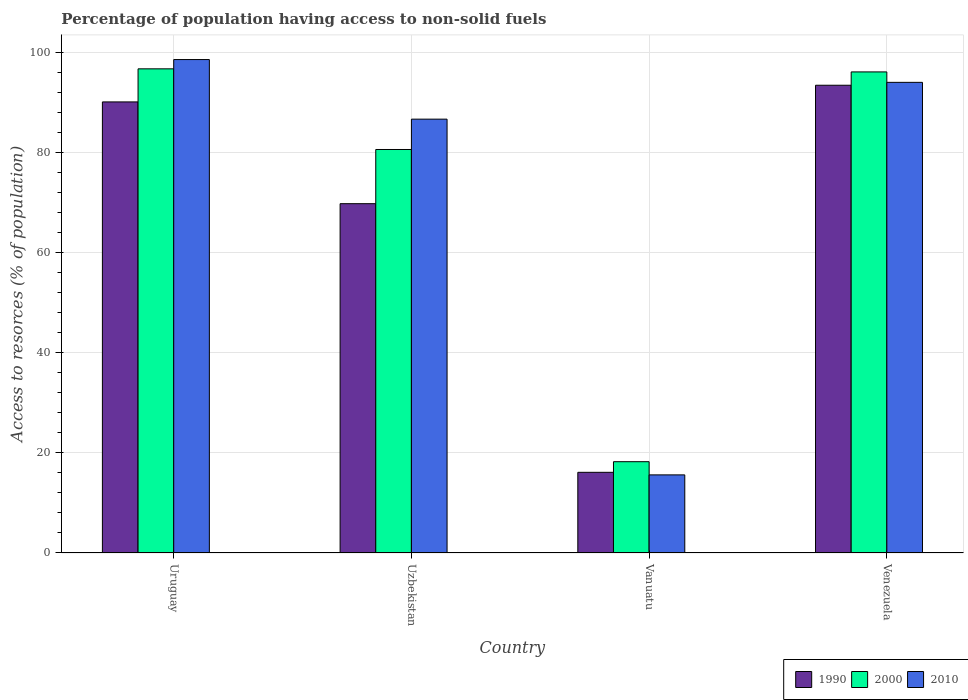Are the number of bars on each tick of the X-axis equal?
Provide a short and direct response. Yes. What is the label of the 1st group of bars from the left?
Provide a succinct answer. Uruguay. What is the percentage of population having access to non-solid fuels in 2010 in Vanuatu?
Make the answer very short. 15.6. Across all countries, what is the maximum percentage of population having access to non-solid fuels in 2010?
Keep it short and to the point. 98.59. Across all countries, what is the minimum percentage of population having access to non-solid fuels in 2000?
Make the answer very short. 18.24. In which country was the percentage of population having access to non-solid fuels in 2000 maximum?
Your response must be concise. Uruguay. In which country was the percentage of population having access to non-solid fuels in 1990 minimum?
Offer a terse response. Vanuatu. What is the total percentage of population having access to non-solid fuels in 2000 in the graph?
Offer a very short reply. 291.7. What is the difference between the percentage of population having access to non-solid fuels in 2010 in Uzbekistan and that in Vanuatu?
Offer a terse response. 71.07. What is the difference between the percentage of population having access to non-solid fuels in 2000 in Venezuela and the percentage of population having access to non-solid fuels in 1990 in Uruguay?
Offer a terse response. 5.99. What is the average percentage of population having access to non-solid fuels in 1990 per country?
Offer a very short reply. 67.37. What is the difference between the percentage of population having access to non-solid fuels of/in 2010 and percentage of population having access to non-solid fuels of/in 2000 in Venezuela?
Make the answer very short. -2.08. In how many countries, is the percentage of population having access to non-solid fuels in 2000 greater than 16 %?
Give a very brief answer. 4. What is the ratio of the percentage of population having access to non-solid fuels in 1990 in Uruguay to that in Vanuatu?
Give a very brief answer. 5.59. Is the percentage of population having access to non-solid fuels in 2010 in Uzbekistan less than that in Venezuela?
Offer a terse response. Yes. What is the difference between the highest and the second highest percentage of population having access to non-solid fuels in 2010?
Offer a terse response. -11.91. What is the difference between the highest and the lowest percentage of population having access to non-solid fuels in 2000?
Offer a very short reply. 78.49. Is the sum of the percentage of population having access to non-solid fuels in 1990 in Uruguay and Vanuatu greater than the maximum percentage of population having access to non-solid fuels in 2000 across all countries?
Offer a terse response. Yes. What does the 3rd bar from the left in Uzbekistan represents?
Offer a very short reply. 2010. What does the 1st bar from the right in Venezuela represents?
Your answer should be compact. 2010. Are the values on the major ticks of Y-axis written in scientific E-notation?
Your answer should be very brief. No. Does the graph contain any zero values?
Offer a very short reply. No. How many legend labels are there?
Your response must be concise. 3. What is the title of the graph?
Offer a terse response. Percentage of population having access to non-solid fuels. What is the label or title of the Y-axis?
Keep it short and to the point. Access to resorces (% of population). What is the Access to resorces (% of population) of 1990 in Uruguay?
Provide a short and direct response. 90.12. What is the Access to resorces (% of population) in 2000 in Uruguay?
Give a very brief answer. 96.73. What is the Access to resorces (% of population) in 2010 in Uruguay?
Your response must be concise. 98.59. What is the Access to resorces (% of population) of 1990 in Uzbekistan?
Offer a terse response. 69.79. What is the Access to resorces (% of population) in 2000 in Uzbekistan?
Offer a terse response. 80.62. What is the Access to resorces (% of population) in 2010 in Uzbekistan?
Offer a very short reply. 86.68. What is the Access to resorces (% of population) in 1990 in Vanuatu?
Your response must be concise. 16.12. What is the Access to resorces (% of population) of 2000 in Vanuatu?
Ensure brevity in your answer.  18.24. What is the Access to resorces (% of population) of 2010 in Vanuatu?
Your response must be concise. 15.6. What is the Access to resorces (% of population) of 1990 in Venezuela?
Ensure brevity in your answer.  93.45. What is the Access to resorces (% of population) in 2000 in Venezuela?
Offer a terse response. 96.12. What is the Access to resorces (% of population) in 2010 in Venezuela?
Provide a succinct answer. 94.03. Across all countries, what is the maximum Access to resorces (% of population) in 1990?
Offer a terse response. 93.45. Across all countries, what is the maximum Access to resorces (% of population) of 2000?
Provide a succinct answer. 96.73. Across all countries, what is the maximum Access to resorces (% of population) in 2010?
Make the answer very short. 98.59. Across all countries, what is the minimum Access to resorces (% of population) of 1990?
Provide a short and direct response. 16.12. Across all countries, what is the minimum Access to resorces (% of population) of 2000?
Offer a terse response. 18.24. Across all countries, what is the minimum Access to resorces (% of population) of 2010?
Make the answer very short. 15.6. What is the total Access to resorces (% of population) of 1990 in the graph?
Your answer should be compact. 269.48. What is the total Access to resorces (% of population) in 2000 in the graph?
Give a very brief answer. 291.7. What is the total Access to resorces (% of population) of 2010 in the graph?
Provide a succinct answer. 294.9. What is the difference between the Access to resorces (% of population) in 1990 in Uruguay and that in Uzbekistan?
Keep it short and to the point. 20.33. What is the difference between the Access to resorces (% of population) of 2000 in Uruguay and that in Uzbekistan?
Make the answer very short. 16.12. What is the difference between the Access to resorces (% of population) in 2010 in Uruguay and that in Uzbekistan?
Your answer should be compact. 11.91. What is the difference between the Access to resorces (% of population) of 1990 in Uruguay and that in Vanuatu?
Give a very brief answer. 74.01. What is the difference between the Access to resorces (% of population) of 2000 in Uruguay and that in Vanuatu?
Give a very brief answer. 78.49. What is the difference between the Access to resorces (% of population) in 2010 in Uruguay and that in Vanuatu?
Give a very brief answer. 82.98. What is the difference between the Access to resorces (% of population) in 1990 in Uruguay and that in Venezuela?
Your response must be concise. -3.33. What is the difference between the Access to resorces (% of population) of 2000 in Uruguay and that in Venezuela?
Ensure brevity in your answer.  0.62. What is the difference between the Access to resorces (% of population) of 2010 in Uruguay and that in Venezuela?
Your answer should be very brief. 4.55. What is the difference between the Access to resorces (% of population) of 1990 in Uzbekistan and that in Vanuatu?
Your response must be concise. 53.67. What is the difference between the Access to resorces (% of population) of 2000 in Uzbekistan and that in Vanuatu?
Give a very brief answer. 62.38. What is the difference between the Access to resorces (% of population) of 2010 in Uzbekistan and that in Vanuatu?
Make the answer very short. 71.07. What is the difference between the Access to resorces (% of population) in 1990 in Uzbekistan and that in Venezuela?
Your response must be concise. -23.66. What is the difference between the Access to resorces (% of population) of 2000 in Uzbekistan and that in Venezuela?
Your response must be concise. -15.5. What is the difference between the Access to resorces (% of population) of 2010 in Uzbekistan and that in Venezuela?
Provide a succinct answer. -7.35. What is the difference between the Access to resorces (% of population) in 1990 in Vanuatu and that in Venezuela?
Your answer should be very brief. -77.34. What is the difference between the Access to resorces (% of population) in 2000 in Vanuatu and that in Venezuela?
Offer a terse response. -77.88. What is the difference between the Access to resorces (% of population) of 2010 in Vanuatu and that in Venezuela?
Your answer should be very brief. -78.43. What is the difference between the Access to resorces (% of population) in 1990 in Uruguay and the Access to resorces (% of population) in 2000 in Uzbekistan?
Make the answer very short. 9.51. What is the difference between the Access to resorces (% of population) in 1990 in Uruguay and the Access to resorces (% of population) in 2010 in Uzbekistan?
Make the answer very short. 3.44. What is the difference between the Access to resorces (% of population) of 2000 in Uruguay and the Access to resorces (% of population) of 2010 in Uzbekistan?
Provide a succinct answer. 10.05. What is the difference between the Access to resorces (% of population) in 1990 in Uruguay and the Access to resorces (% of population) in 2000 in Vanuatu?
Ensure brevity in your answer.  71.88. What is the difference between the Access to resorces (% of population) in 1990 in Uruguay and the Access to resorces (% of population) in 2010 in Vanuatu?
Give a very brief answer. 74.52. What is the difference between the Access to resorces (% of population) in 2000 in Uruguay and the Access to resorces (% of population) in 2010 in Vanuatu?
Ensure brevity in your answer.  81.13. What is the difference between the Access to resorces (% of population) in 1990 in Uruguay and the Access to resorces (% of population) in 2000 in Venezuela?
Your response must be concise. -5.99. What is the difference between the Access to resorces (% of population) in 1990 in Uruguay and the Access to resorces (% of population) in 2010 in Venezuela?
Give a very brief answer. -3.91. What is the difference between the Access to resorces (% of population) of 2000 in Uruguay and the Access to resorces (% of population) of 2010 in Venezuela?
Offer a terse response. 2.7. What is the difference between the Access to resorces (% of population) of 1990 in Uzbekistan and the Access to resorces (% of population) of 2000 in Vanuatu?
Provide a short and direct response. 51.55. What is the difference between the Access to resorces (% of population) in 1990 in Uzbekistan and the Access to resorces (% of population) in 2010 in Vanuatu?
Offer a terse response. 54.18. What is the difference between the Access to resorces (% of population) in 2000 in Uzbekistan and the Access to resorces (% of population) in 2010 in Vanuatu?
Provide a short and direct response. 65.01. What is the difference between the Access to resorces (% of population) of 1990 in Uzbekistan and the Access to resorces (% of population) of 2000 in Venezuela?
Keep it short and to the point. -26.33. What is the difference between the Access to resorces (% of population) in 1990 in Uzbekistan and the Access to resorces (% of population) in 2010 in Venezuela?
Your answer should be compact. -24.24. What is the difference between the Access to resorces (% of population) of 2000 in Uzbekistan and the Access to resorces (% of population) of 2010 in Venezuela?
Your answer should be compact. -13.42. What is the difference between the Access to resorces (% of population) of 1990 in Vanuatu and the Access to resorces (% of population) of 2000 in Venezuela?
Provide a succinct answer. -80. What is the difference between the Access to resorces (% of population) in 1990 in Vanuatu and the Access to resorces (% of population) in 2010 in Venezuela?
Offer a very short reply. -77.91. What is the difference between the Access to resorces (% of population) of 2000 in Vanuatu and the Access to resorces (% of population) of 2010 in Venezuela?
Keep it short and to the point. -75.79. What is the average Access to resorces (% of population) in 1990 per country?
Your answer should be very brief. 67.37. What is the average Access to resorces (% of population) in 2000 per country?
Give a very brief answer. 72.93. What is the average Access to resorces (% of population) of 2010 per country?
Ensure brevity in your answer.  73.72. What is the difference between the Access to resorces (% of population) in 1990 and Access to resorces (% of population) in 2000 in Uruguay?
Keep it short and to the point. -6.61. What is the difference between the Access to resorces (% of population) in 1990 and Access to resorces (% of population) in 2010 in Uruguay?
Provide a short and direct response. -8.46. What is the difference between the Access to resorces (% of population) in 2000 and Access to resorces (% of population) in 2010 in Uruguay?
Give a very brief answer. -1.85. What is the difference between the Access to resorces (% of population) in 1990 and Access to resorces (% of population) in 2000 in Uzbekistan?
Your answer should be very brief. -10.83. What is the difference between the Access to resorces (% of population) in 1990 and Access to resorces (% of population) in 2010 in Uzbekistan?
Your answer should be very brief. -16.89. What is the difference between the Access to resorces (% of population) of 2000 and Access to resorces (% of population) of 2010 in Uzbekistan?
Make the answer very short. -6.06. What is the difference between the Access to resorces (% of population) of 1990 and Access to resorces (% of population) of 2000 in Vanuatu?
Provide a succinct answer. -2.12. What is the difference between the Access to resorces (% of population) in 1990 and Access to resorces (% of population) in 2010 in Vanuatu?
Offer a very short reply. 0.51. What is the difference between the Access to resorces (% of population) in 2000 and Access to resorces (% of population) in 2010 in Vanuatu?
Keep it short and to the point. 2.63. What is the difference between the Access to resorces (% of population) of 1990 and Access to resorces (% of population) of 2000 in Venezuela?
Your response must be concise. -2.66. What is the difference between the Access to resorces (% of population) of 1990 and Access to resorces (% of population) of 2010 in Venezuela?
Your answer should be very brief. -0.58. What is the difference between the Access to resorces (% of population) in 2000 and Access to resorces (% of population) in 2010 in Venezuela?
Offer a very short reply. 2.08. What is the ratio of the Access to resorces (% of population) of 1990 in Uruguay to that in Uzbekistan?
Your answer should be very brief. 1.29. What is the ratio of the Access to resorces (% of population) of 2000 in Uruguay to that in Uzbekistan?
Offer a terse response. 1.2. What is the ratio of the Access to resorces (% of population) in 2010 in Uruguay to that in Uzbekistan?
Offer a terse response. 1.14. What is the ratio of the Access to resorces (% of population) in 1990 in Uruguay to that in Vanuatu?
Give a very brief answer. 5.59. What is the ratio of the Access to resorces (% of population) of 2000 in Uruguay to that in Vanuatu?
Keep it short and to the point. 5.3. What is the ratio of the Access to resorces (% of population) of 2010 in Uruguay to that in Vanuatu?
Provide a short and direct response. 6.32. What is the ratio of the Access to resorces (% of population) of 1990 in Uruguay to that in Venezuela?
Keep it short and to the point. 0.96. What is the ratio of the Access to resorces (% of population) of 2000 in Uruguay to that in Venezuela?
Provide a short and direct response. 1.01. What is the ratio of the Access to resorces (% of population) in 2010 in Uruguay to that in Venezuela?
Ensure brevity in your answer.  1.05. What is the ratio of the Access to resorces (% of population) of 1990 in Uzbekistan to that in Vanuatu?
Your answer should be very brief. 4.33. What is the ratio of the Access to resorces (% of population) in 2000 in Uzbekistan to that in Vanuatu?
Your answer should be compact. 4.42. What is the ratio of the Access to resorces (% of population) of 2010 in Uzbekistan to that in Vanuatu?
Ensure brevity in your answer.  5.55. What is the ratio of the Access to resorces (% of population) in 1990 in Uzbekistan to that in Venezuela?
Ensure brevity in your answer.  0.75. What is the ratio of the Access to resorces (% of population) in 2000 in Uzbekistan to that in Venezuela?
Make the answer very short. 0.84. What is the ratio of the Access to resorces (% of population) of 2010 in Uzbekistan to that in Venezuela?
Your answer should be compact. 0.92. What is the ratio of the Access to resorces (% of population) in 1990 in Vanuatu to that in Venezuela?
Offer a very short reply. 0.17. What is the ratio of the Access to resorces (% of population) in 2000 in Vanuatu to that in Venezuela?
Provide a succinct answer. 0.19. What is the ratio of the Access to resorces (% of population) of 2010 in Vanuatu to that in Venezuela?
Keep it short and to the point. 0.17. What is the difference between the highest and the second highest Access to resorces (% of population) of 1990?
Provide a succinct answer. 3.33. What is the difference between the highest and the second highest Access to resorces (% of population) of 2000?
Give a very brief answer. 0.62. What is the difference between the highest and the second highest Access to resorces (% of population) of 2010?
Offer a very short reply. 4.55. What is the difference between the highest and the lowest Access to resorces (% of population) of 1990?
Provide a short and direct response. 77.34. What is the difference between the highest and the lowest Access to resorces (% of population) of 2000?
Ensure brevity in your answer.  78.49. What is the difference between the highest and the lowest Access to resorces (% of population) of 2010?
Your response must be concise. 82.98. 